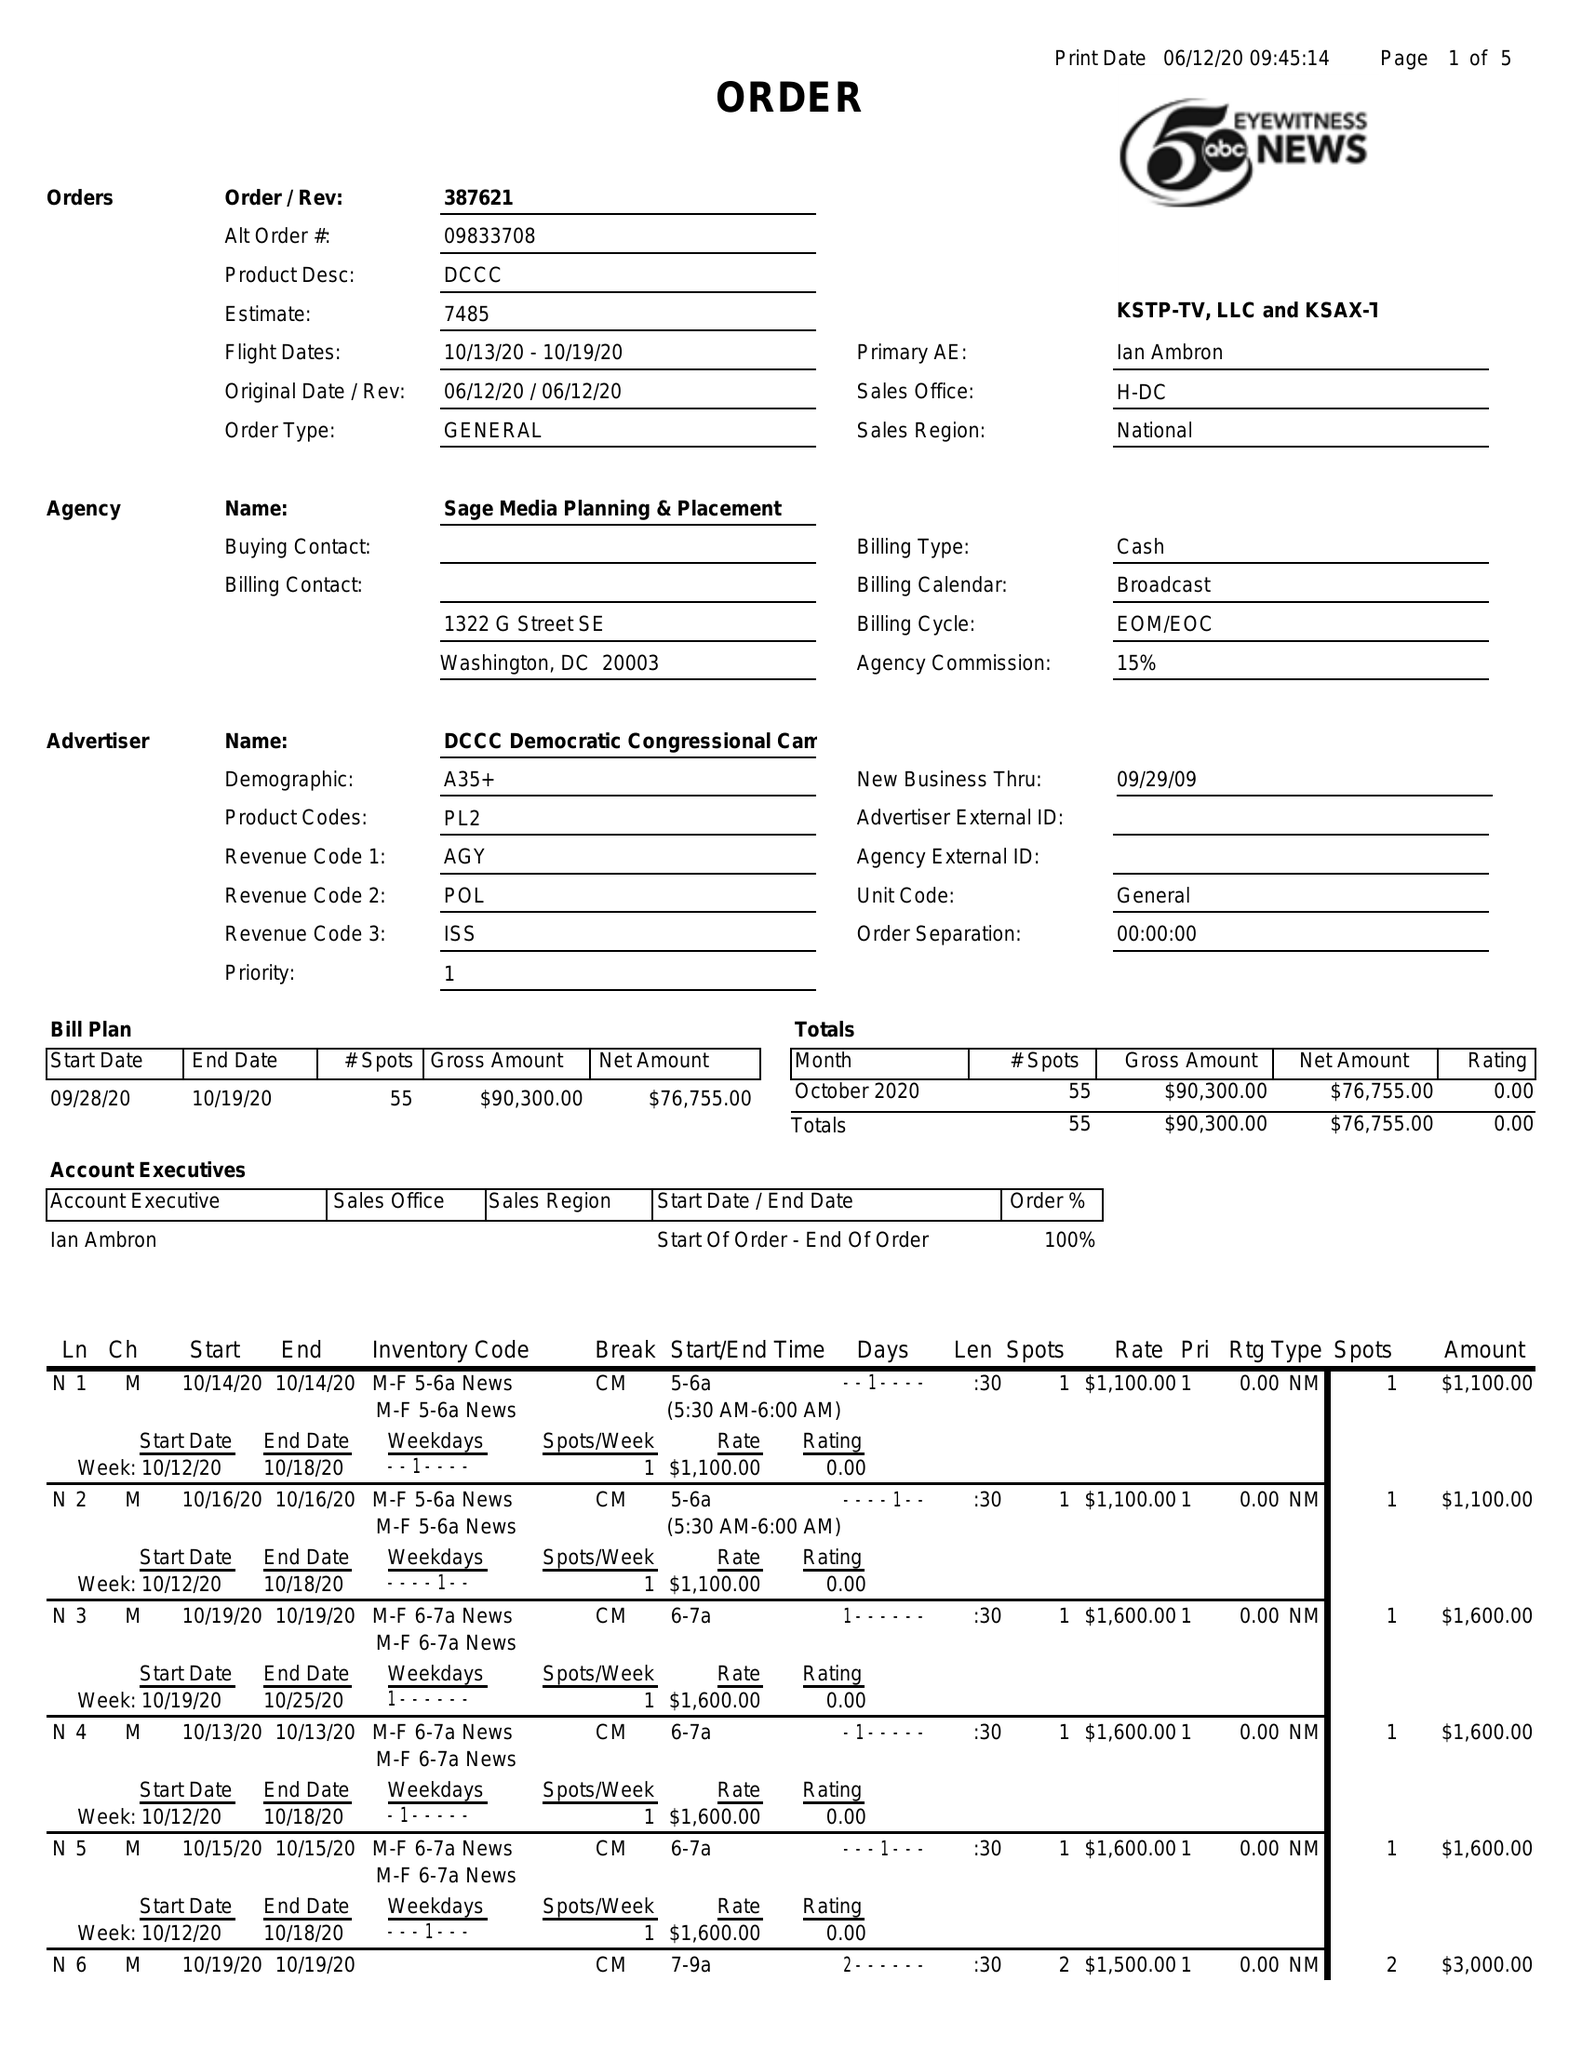What is the value for the contract_num?
Answer the question using a single word or phrase. 387621 